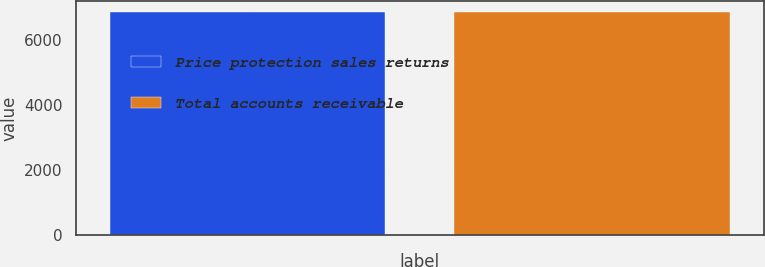Convert chart to OTSL. <chart><loc_0><loc_0><loc_500><loc_500><bar_chart><fcel>Price protection sales returns<fcel>Total accounts receivable<nl><fcel>6849<fcel>6849.1<nl></chart> 